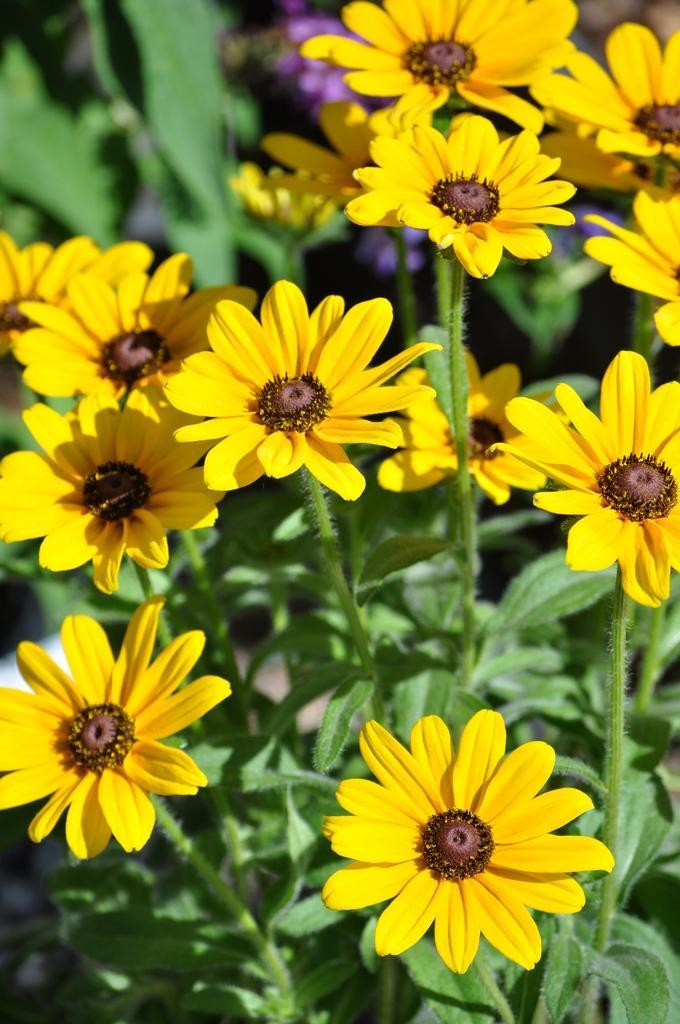Could you give a brief overview of what you see in this image? In this image we can see plants with flowers. In the background the image is blur but we can see plants and flowers. 